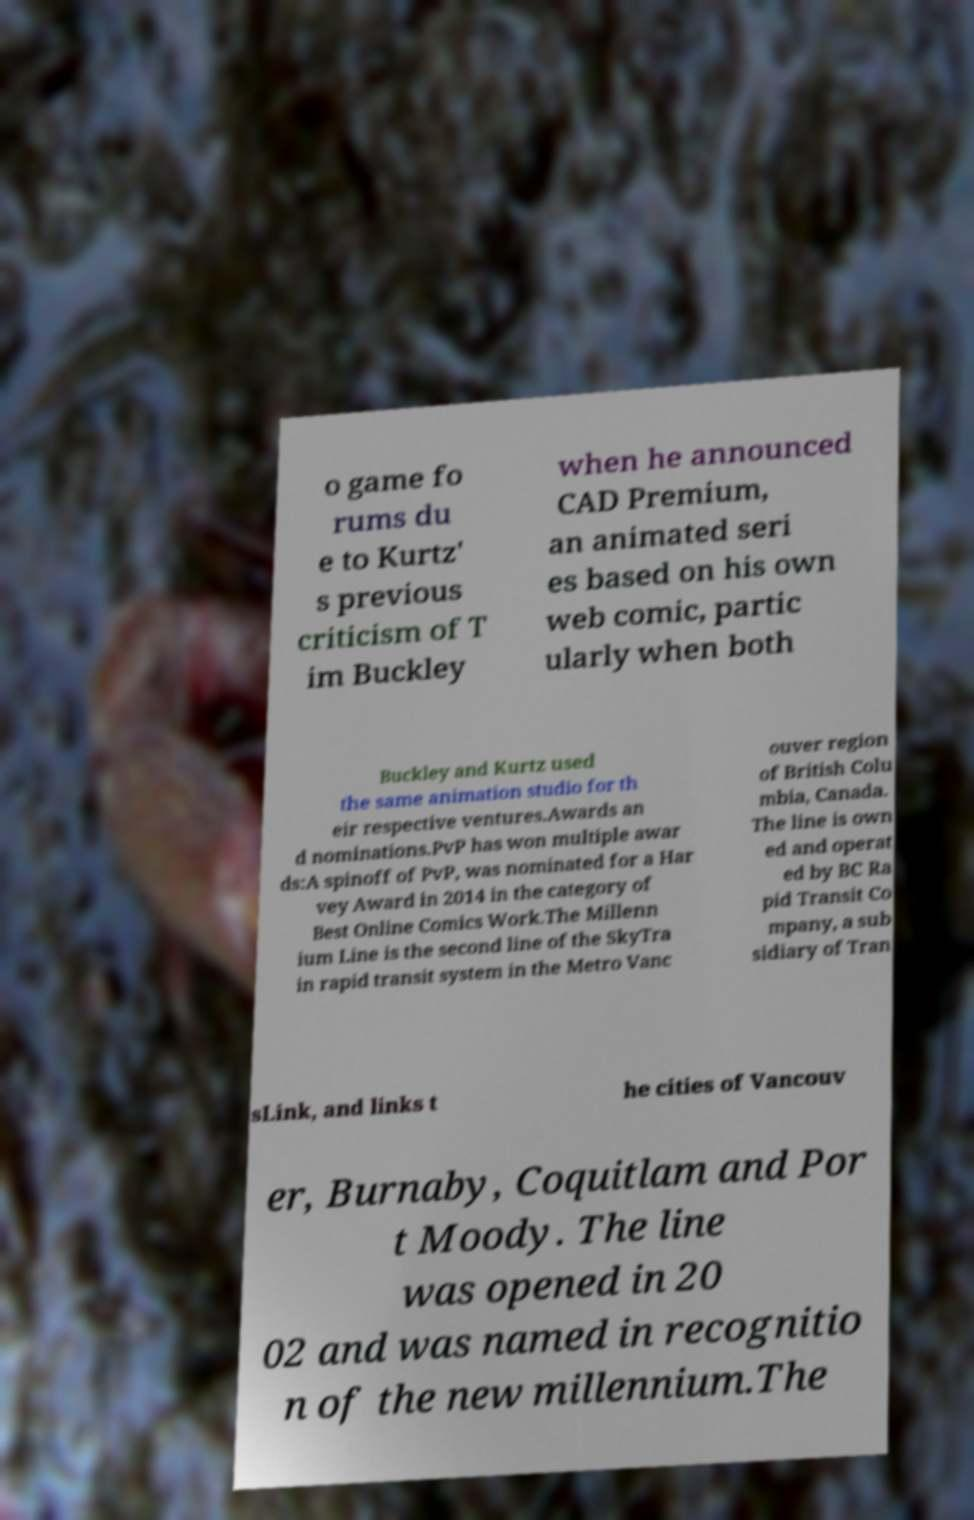Can you read and provide the text displayed in the image?This photo seems to have some interesting text. Can you extract and type it out for me? o game fo rums du e to Kurtz' s previous criticism of T im Buckley when he announced CAD Premium, an animated seri es based on his own web comic, partic ularly when both Buckley and Kurtz used the same animation studio for th eir respective ventures.Awards an d nominations.PvP has won multiple awar ds:A spinoff of PvP, was nominated for a Har vey Award in 2014 in the category of Best Online Comics Work.The Millenn ium Line is the second line of the SkyTra in rapid transit system in the Metro Vanc ouver region of British Colu mbia, Canada. The line is own ed and operat ed by BC Ra pid Transit Co mpany, a sub sidiary of Tran sLink, and links t he cities of Vancouv er, Burnaby, Coquitlam and Por t Moody. The line was opened in 20 02 and was named in recognitio n of the new millennium.The 